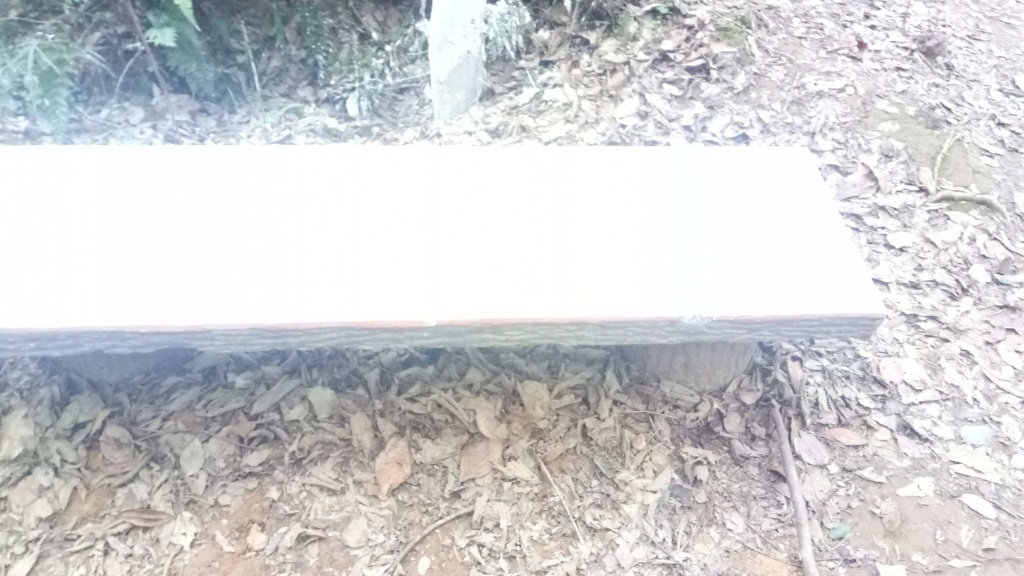What material is the bench made from? The bench appears to be made from a solid piece of wood, characterized by the natural grain patterns and the smooth, even surface that suggests it has been treated or sealed for outdoor use. Does this bench look like it's in a public or private space? Given the natural surroundings, absence of man-made structures in the visible area, and the simple, rustic style of the bench, it is likely situated in a public park or a similar communal outdoor space intended for visitors to rest and enjoy the environment. 